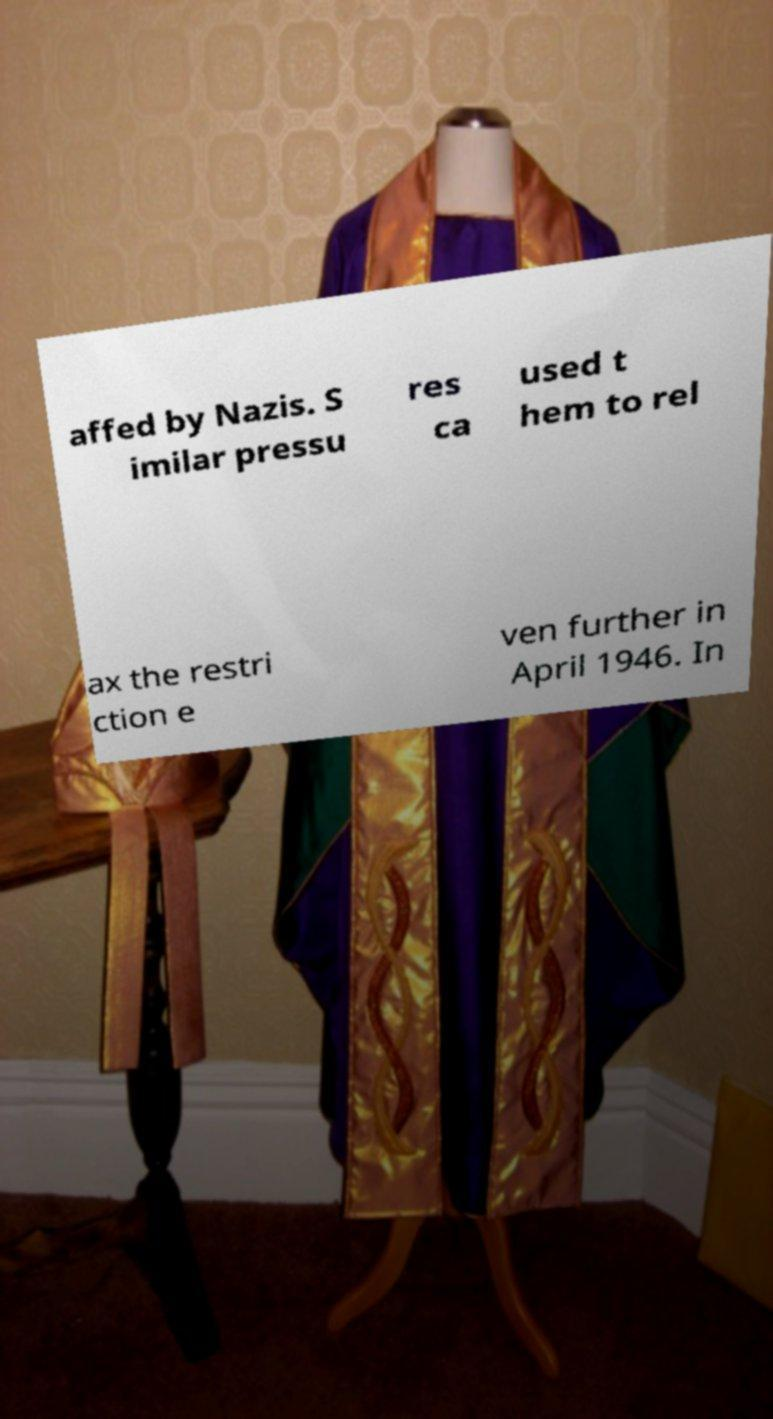Can you read and provide the text displayed in the image?This photo seems to have some interesting text. Can you extract and type it out for me? affed by Nazis. S imilar pressu res ca used t hem to rel ax the restri ction e ven further in April 1946. In 